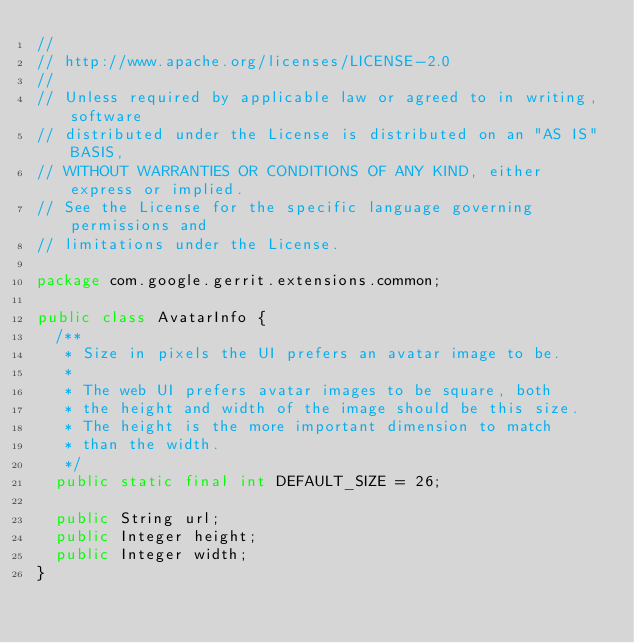Convert code to text. <code><loc_0><loc_0><loc_500><loc_500><_Java_>//
// http://www.apache.org/licenses/LICENSE-2.0
//
// Unless required by applicable law or agreed to in writing, software
// distributed under the License is distributed on an "AS IS" BASIS,
// WITHOUT WARRANTIES OR CONDITIONS OF ANY KIND, either express or implied.
// See the License for the specific language governing permissions and
// limitations under the License.

package com.google.gerrit.extensions.common;

public class AvatarInfo {
  /**
   * Size in pixels the UI prefers an avatar image to be.
   *
   * The web UI prefers avatar images to be square, both
   * the height and width of the image should be this size.
   * The height is the more important dimension to match
   * than the width.
   */
  public static final int DEFAULT_SIZE = 26;

  public String url;
  public Integer height;
  public Integer width;
}
</code> 